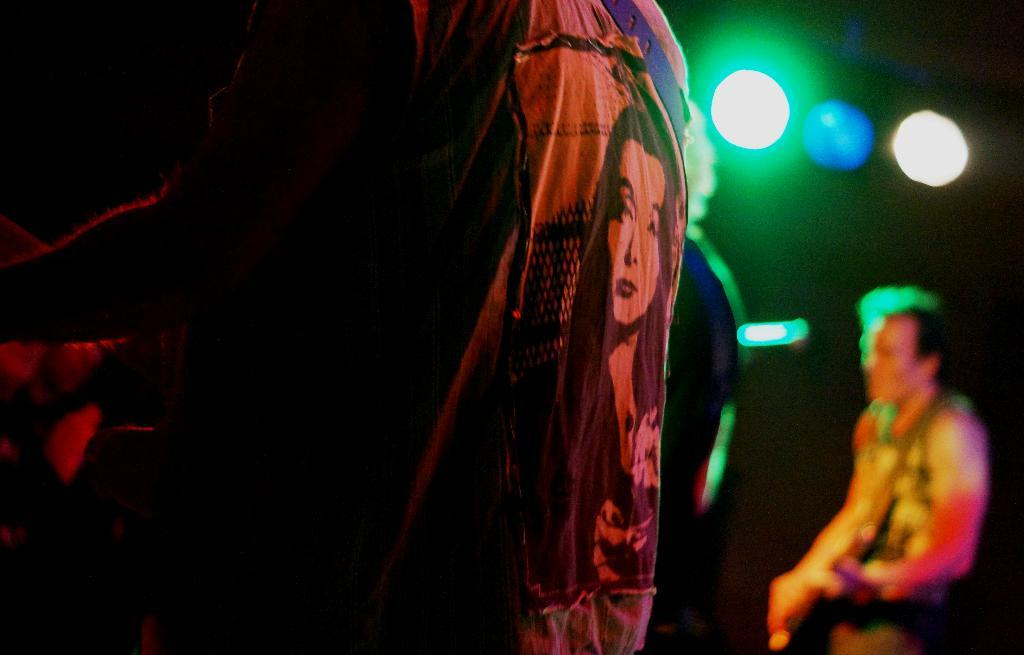What are the people in the image doing? The people in the image are playing musical instruments. Can you describe any specific details about the clothing in the image? There is a woman's picture on a jacket in the image. What can be seen in the image that provides illumination? There are lights visible in the image. How would you describe the overall lighting conditions in the image? The background of the image is dark. What type of weather can be seen in the image? There is no indication of weather in the image; it only shows people playing musical instruments, a jacket with a woman's picture, lights, and a dark background. Can you tell me how many horses are present in the image? There are no horses present in the image. 